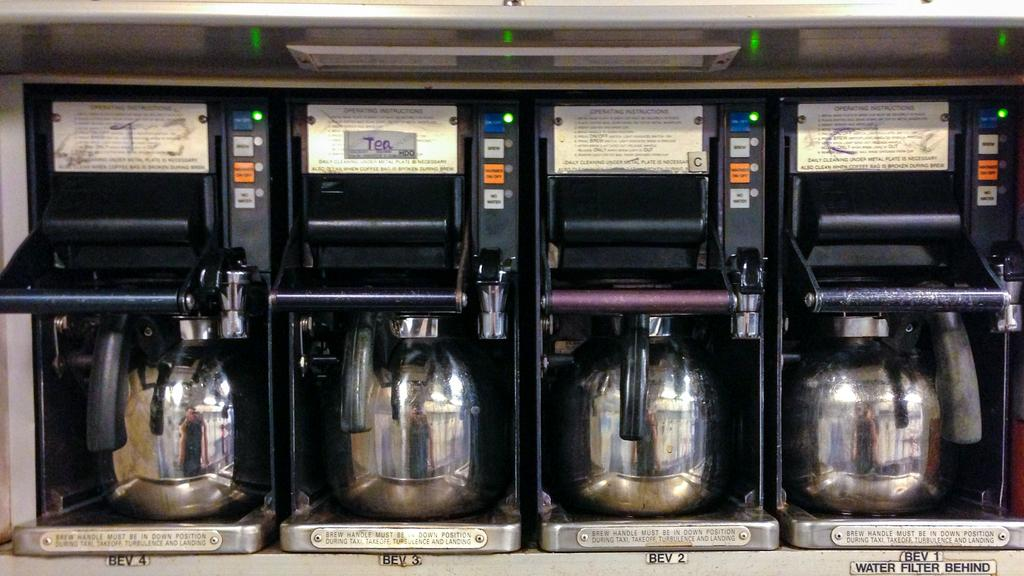<image>
Render a clear and concise summary of the photo. One of the options to drink is tea. 